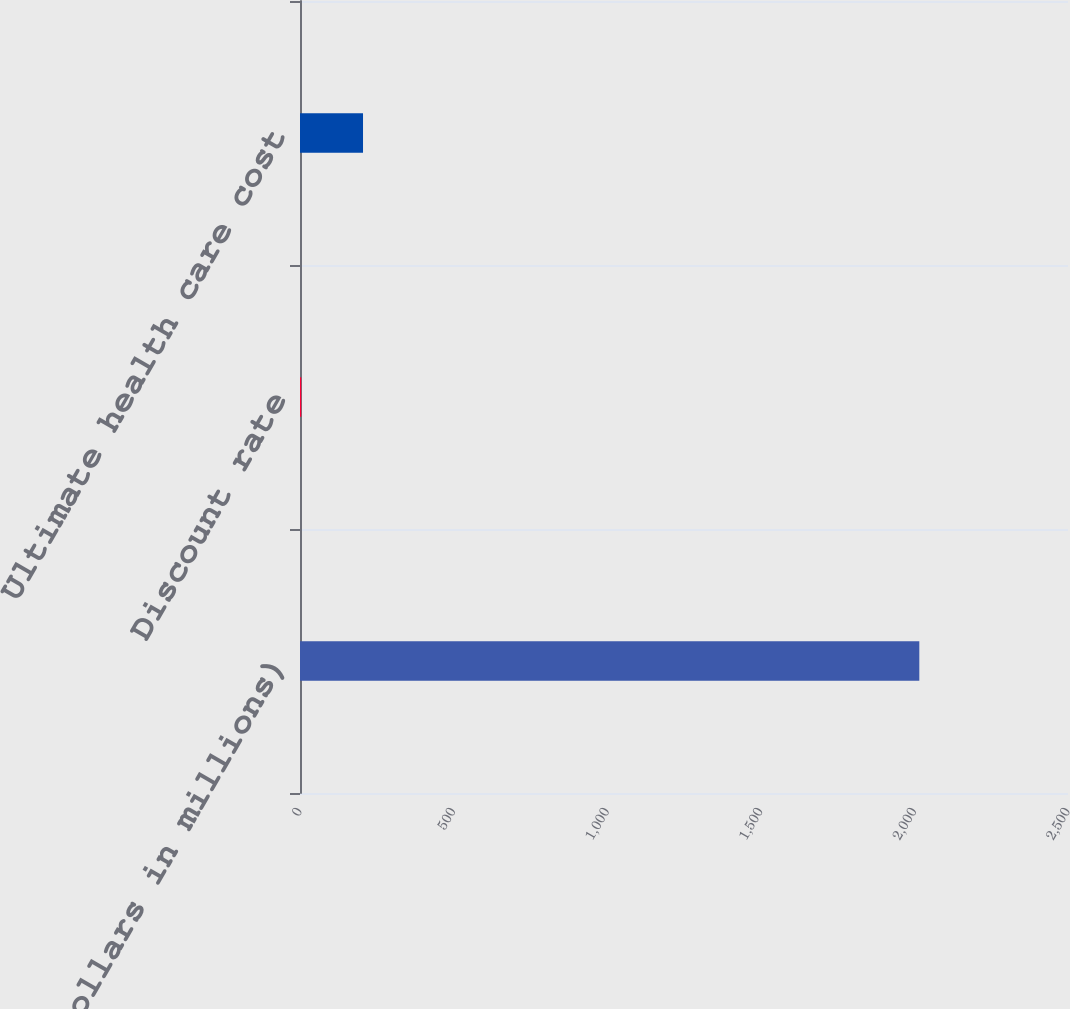Convert chart to OTSL. <chart><loc_0><loc_0><loc_500><loc_500><bar_chart><fcel>(dollars in millions)<fcel>Discount rate<fcel>Ultimate health care cost<nl><fcel>2016<fcel>3.93<fcel>205.14<nl></chart> 